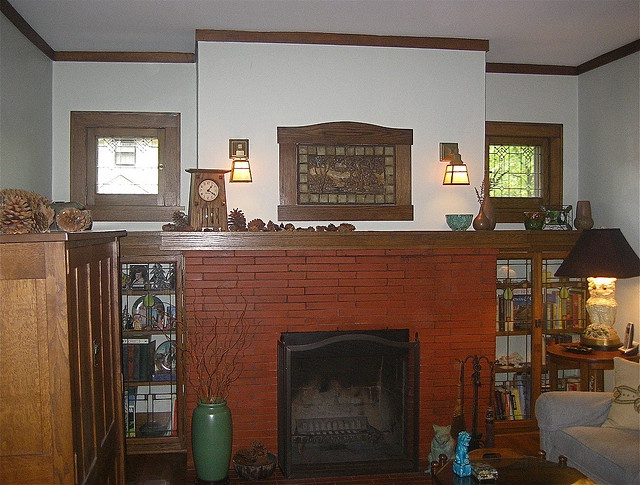Describe the objects in this image and their specific colors. I can see couch in black and gray tones, vase in black and darkgreen tones, book in black, maroon, gray, and olive tones, cat in black, gray, and darkgreen tones, and book in black and gray tones in this image. 